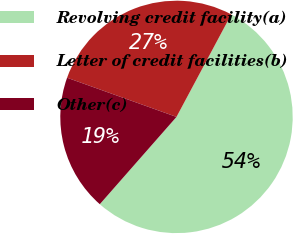Convert chart. <chart><loc_0><loc_0><loc_500><loc_500><pie_chart><fcel>Revolving credit facility(a)<fcel>Letter of credit facilities(b)<fcel>Other(c)<nl><fcel>53.66%<fcel>27.34%<fcel>19.0%<nl></chart> 